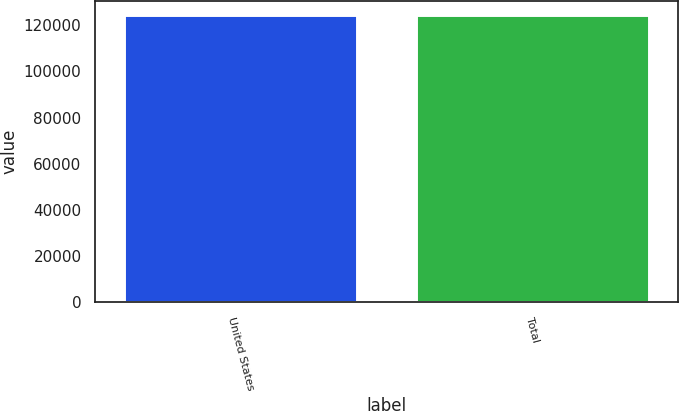Convert chart to OTSL. <chart><loc_0><loc_0><loc_500><loc_500><bar_chart><fcel>United States<fcel>Total<nl><fcel>124326<fcel>124326<nl></chart> 